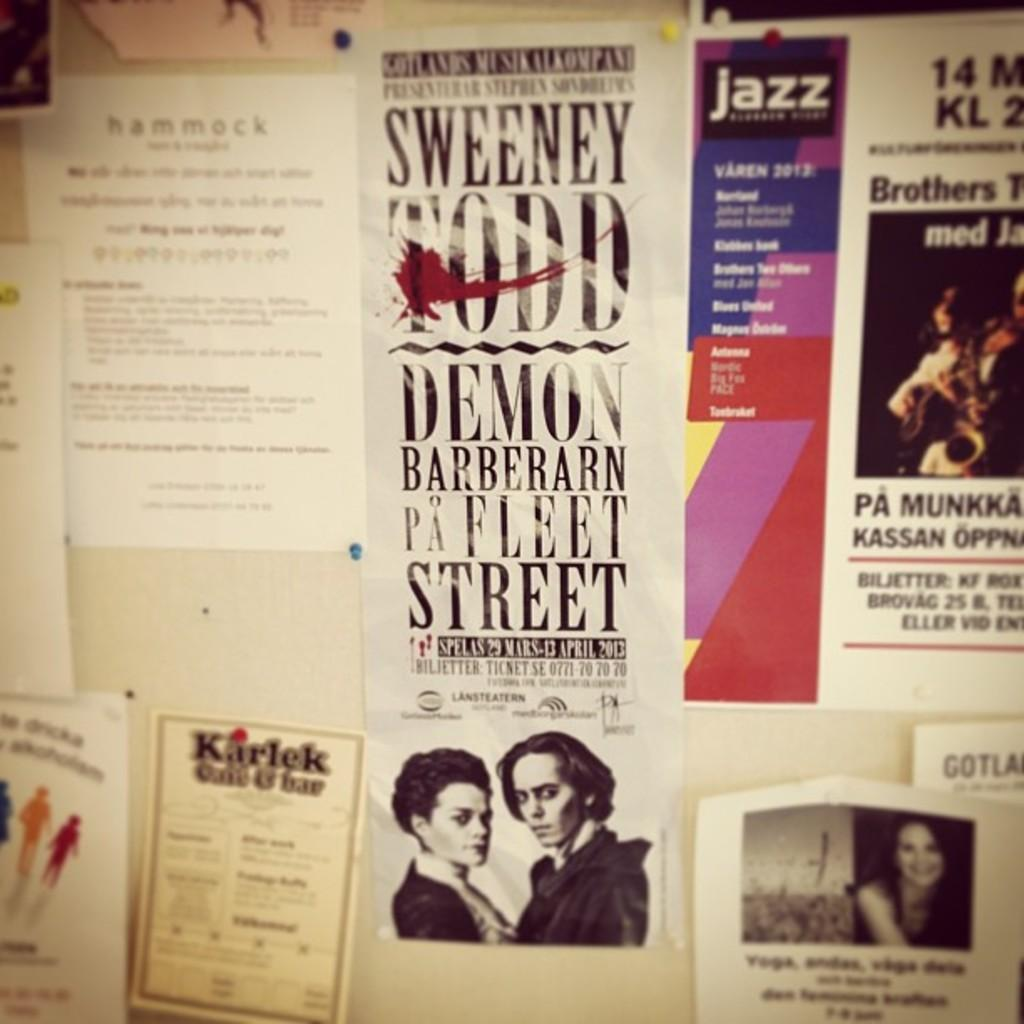<image>
Describe the image concisely. the word demon is on a large poster 